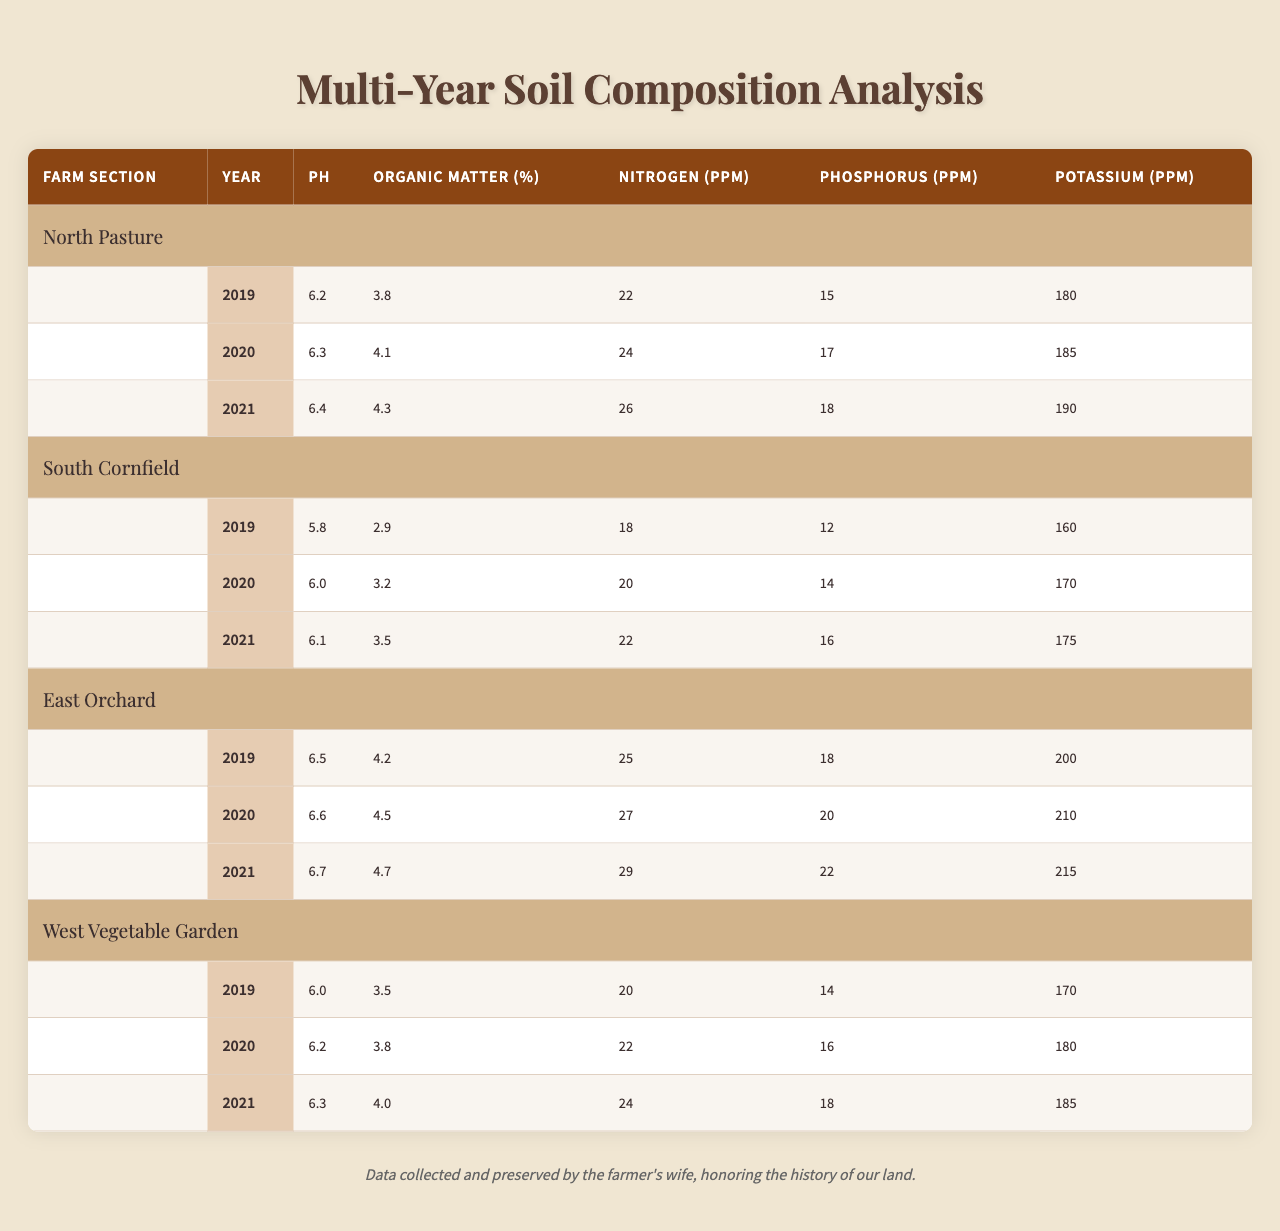What is the pH level of the East Orchard in 2021? In the table, I locate the row for the East Orchard and the corresponding year 2021. The pH level listed in that row is 6.7.
Answer: 6.7 Which farm section had the highest organic matter percentage in 2020? Looking through the 2020 data for each farm section, I find that the East Orchard has 4.5%, which is higher than the others.
Answer: East Orchard What is the difference in potassium levels between the West Vegetable Garden in 2019 and 2021? I check the potassium values for the West Vegetable Garden for both years: 2019 has 170 ppm and 2021 has 185 ppm. The difference is calculated as 185 - 170 = 15 ppm.
Answer: 15 ppm What year saw the lowest nitrogen level in the South Cornfield? I review the nitrogen values for the South Cornfield, which are 18 ppm in 2019, 20 ppm in 2020, and 22 ppm in 2021. The lowest value is 18 ppm in 2019.
Answer: 2019 Is the average pH level for the North Pasture across all years greater than 6.2? I calculate the average pH level for the North Pasture: (6.2 + 6.3 + 6.4) / 3 = 6.3. Since 6.3 is greater than 6.2, the statement is true.
Answer: Yes How much did the phosphorus level increase in the East Orchard from 2019 to 2021? I look at the phosphorus values: 2019 has 18 ppm and 2021 has 22 ppm. The increase is 22 - 18 = 4 ppm.
Answer: 4 ppm Which Section consistently had a higher potassium level than 180 ppm over the analyzed years? I check each section for potassium levels across the years: the North Pasture, East Orchard, and West Vegetable Garden all had values greater than 180 ppm consistently.
Answer: North Pasture, East Orchard What is the average organic matter percentage for the South Cornfield over the three years? I find the organic matter percentages: 2.9% (2019), 3.2% (2020), and 3.5% (2021). Adding them gives 2.9 + 3.2 + 3.5 = 9.6. Dividing by 3 gives an average of 9.6 / 3 = 3.2%.
Answer: 3.2% In which year did the West Vegetable Garden experience the most significant increase in pH level? I examine the pH levels for the West Vegetable Garden: 6.0 (2019), 6.2 (2020), and 6.3 (2021). The biggest increase is from 6.0 to 6.2, which is 0.2 units, from 2019 to 2020.
Answer: 2020 Was the organic matter percentage in 2020 higher in the North Pasture than in the West Vegetable Garden? I check the values: North Pasture is 4.1% and West Vegetable Garden is 3.8% for 2020. Since 4.1% is greater than 3.8%, the statement is true.
Answer: Yes 